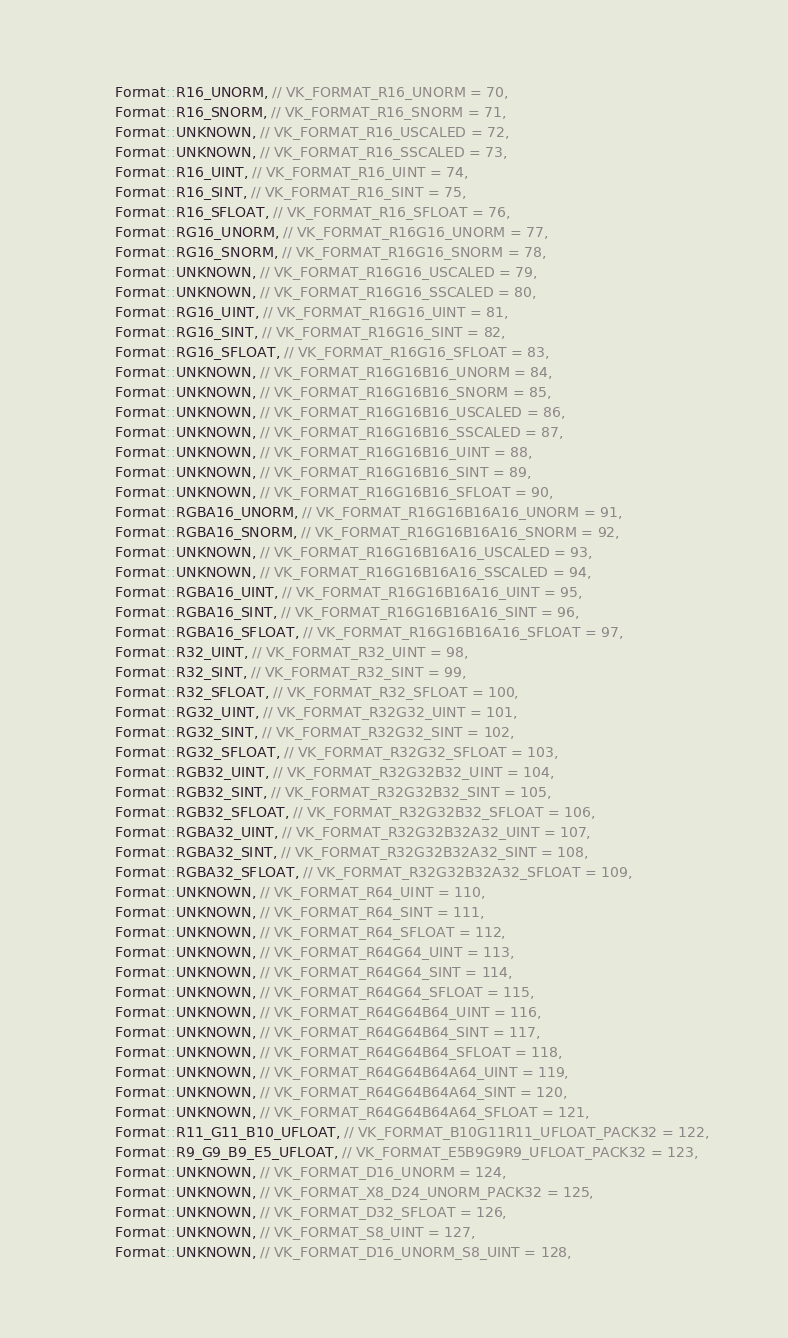Convert code to text. <code><loc_0><loc_0><loc_500><loc_500><_C_>        Format::R16_UNORM, // VK_FORMAT_R16_UNORM = 70,
        Format::R16_SNORM, // VK_FORMAT_R16_SNORM = 71,
        Format::UNKNOWN, // VK_FORMAT_R16_USCALED = 72,
        Format::UNKNOWN, // VK_FORMAT_R16_SSCALED = 73,
        Format::R16_UINT, // VK_FORMAT_R16_UINT = 74,
        Format::R16_SINT, // VK_FORMAT_R16_SINT = 75,
        Format::R16_SFLOAT, // VK_FORMAT_R16_SFLOAT = 76,
        Format::RG16_UNORM, // VK_FORMAT_R16G16_UNORM = 77,
        Format::RG16_SNORM, // VK_FORMAT_R16G16_SNORM = 78,
        Format::UNKNOWN, // VK_FORMAT_R16G16_USCALED = 79,
        Format::UNKNOWN, // VK_FORMAT_R16G16_SSCALED = 80,
        Format::RG16_UINT, // VK_FORMAT_R16G16_UINT = 81,
        Format::RG16_SINT, // VK_FORMAT_R16G16_SINT = 82,
        Format::RG16_SFLOAT, // VK_FORMAT_R16G16_SFLOAT = 83,
        Format::UNKNOWN, // VK_FORMAT_R16G16B16_UNORM = 84,
        Format::UNKNOWN, // VK_FORMAT_R16G16B16_SNORM = 85,
        Format::UNKNOWN, // VK_FORMAT_R16G16B16_USCALED = 86,
        Format::UNKNOWN, // VK_FORMAT_R16G16B16_SSCALED = 87,
        Format::UNKNOWN, // VK_FORMAT_R16G16B16_UINT = 88,
        Format::UNKNOWN, // VK_FORMAT_R16G16B16_SINT = 89,
        Format::UNKNOWN, // VK_FORMAT_R16G16B16_SFLOAT = 90,
        Format::RGBA16_UNORM, // VK_FORMAT_R16G16B16A16_UNORM = 91,
        Format::RGBA16_SNORM, // VK_FORMAT_R16G16B16A16_SNORM = 92,
        Format::UNKNOWN, // VK_FORMAT_R16G16B16A16_USCALED = 93,
        Format::UNKNOWN, // VK_FORMAT_R16G16B16A16_SSCALED = 94,
        Format::RGBA16_UINT, // VK_FORMAT_R16G16B16A16_UINT = 95,
        Format::RGBA16_SINT, // VK_FORMAT_R16G16B16A16_SINT = 96,
        Format::RGBA16_SFLOAT, // VK_FORMAT_R16G16B16A16_SFLOAT = 97,
        Format::R32_UINT, // VK_FORMAT_R32_UINT = 98,
        Format::R32_SINT, // VK_FORMAT_R32_SINT = 99,
        Format::R32_SFLOAT, // VK_FORMAT_R32_SFLOAT = 100,
        Format::RG32_UINT, // VK_FORMAT_R32G32_UINT = 101,
        Format::RG32_SINT, // VK_FORMAT_R32G32_SINT = 102,
        Format::RG32_SFLOAT, // VK_FORMAT_R32G32_SFLOAT = 103,
        Format::RGB32_UINT, // VK_FORMAT_R32G32B32_UINT = 104,
        Format::RGB32_SINT, // VK_FORMAT_R32G32B32_SINT = 105,
        Format::RGB32_SFLOAT, // VK_FORMAT_R32G32B32_SFLOAT = 106,
        Format::RGBA32_UINT, // VK_FORMAT_R32G32B32A32_UINT = 107,
        Format::RGBA32_SINT, // VK_FORMAT_R32G32B32A32_SINT = 108,
        Format::RGBA32_SFLOAT, // VK_FORMAT_R32G32B32A32_SFLOAT = 109,
        Format::UNKNOWN, // VK_FORMAT_R64_UINT = 110,
        Format::UNKNOWN, // VK_FORMAT_R64_SINT = 111,
        Format::UNKNOWN, // VK_FORMAT_R64_SFLOAT = 112,
        Format::UNKNOWN, // VK_FORMAT_R64G64_UINT = 113,
        Format::UNKNOWN, // VK_FORMAT_R64G64_SINT = 114,
        Format::UNKNOWN, // VK_FORMAT_R64G64_SFLOAT = 115,
        Format::UNKNOWN, // VK_FORMAT_R64G64B64_UINT = 116,
        Format::UNKNOWN, // VK_FORMAT_R64G64B64_SINT = 117,
        Format::UNKNOWN, // VK_FORMAT_R64G64B64_SFLOAT = 118,
        Format::UNKNOWN, // VK_FORMAT_R64G64B64A64_UINT = 119,
        Format::UNKNOWN, // VK_FORMAT_R64G64B64A64_SINT = 120,
        Format::UNKNOWN, // VK_FORMAT_R64G64B64A64_SFLOAT = 121,
        Format::R11_G11_B10_UFLOAT, // VK_FORMAT_B10G11R11_UFLOAT_PACK32 = 122,
        Format::R9_G9_B9_E5_UFLOAT, // VK_FORMAT_E5B9G9R9_UFLOAT_PACK32 = 123,
        Format::UNKNOWN, // VK_FORMAT_D16_UNORM = 124,
        Format::UNKNOWN, // VK_FORMAT_X8_D24_UNORM_PACK32 = 125,
        Format::UNKNOWN, // VK_FORMAT_D32_SFLOAT = 126,
        Format::UNKNOWN, // VK_FORMAT_S8_UINT = 127,
        Format::UNKNOWN, // VK_FORMAT_D16_UNORM_S8_UINT = 128,</code> 